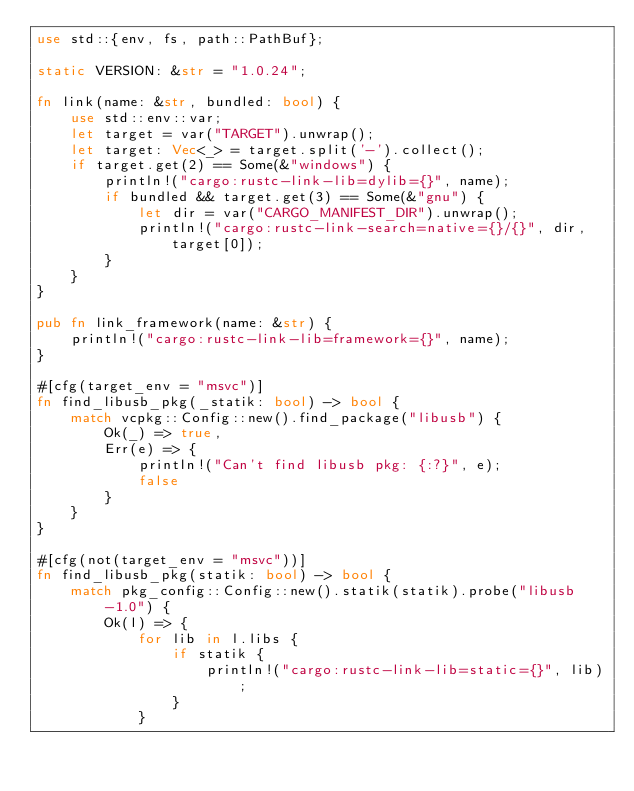Convert code to text. <code><loc_0><loc_0><loc_500><loc_500><_Rust_>use std::{env, fs, path::PathBuf};

static VERSION: &str = "1.0.24";

fn link(name: &str, bundled: bool) {
    use std::env::var;
    let target = var("TARGET").unwrap();
    let target: Vec<_> = target.split('-').collect();
    if target.get(2) == Some(&"windows") {
        println!("cargo:rustc-link-lib=dylib={}", name);
        if bundled && target.get(3) == Some(&"gnu") {
            let dir = var("CARGO_MANIFEST_DIR").unwrap();
            println!("cargo:rustc-link-search=native={}/{}", dir, target[0]);
        }
    }
}

pub fn link_framework(name: &str) {
    println!("cargo:rustc-link-lib=framework={}", name);
}

#[cfg(target_env = "msvc")]
fn find_libusb_pkg(_statik: bool) -> bool {
    match vcpkg::Config::new().find_package("libusb") {
        Ok(_) => true,
        Err(e) => {
            println!("Can't find libusb pkg: {:?}", e);
            false
        }
    }
}

#[cfg(not(target_env = "msvc"))]
fn find_libusb_pkg(statik: bool) -> bool {
    match pkg_config::Config::new().statik(statik).probe("libusb-1.0") {
        Ok(l) => {
            for lib in l.libs {
                if statik {
                    println!("cargo:rustc-link-lib=static={}", lib);
                }
            }</code> 